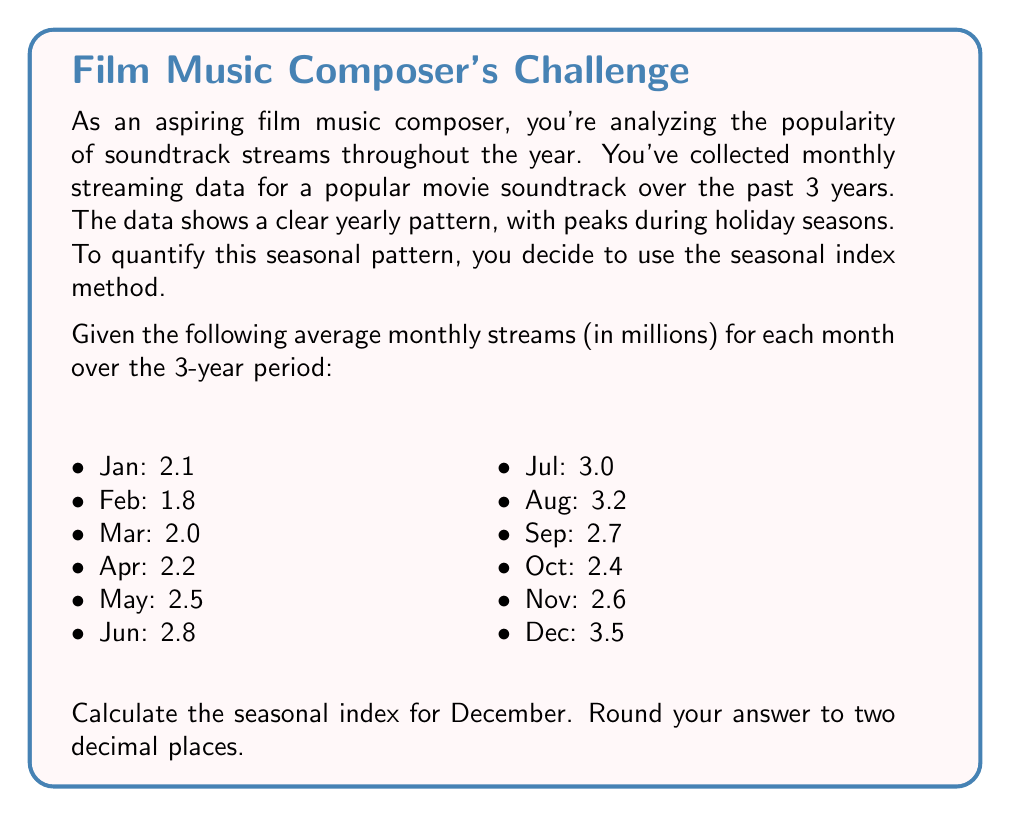Could you help me with this problem? To calculate the seasonal index for December, we'll follow these steps:

1. Calculate the grand mean (overall average) of all monthly averages:
   $$\text{Grand Mean} = \frac{\sum_{i=1}^{12} \text{Monthly Average}_i}{12}$$
   
   $$\text{Grand Mean} = \frac{2.1 + 1.8 + 2.0 + 2.2 + 2.5 + 2.8 + 3.0 + 3.2 + 2.7 + 2.4 + 2.6 + 3.5}{12} = 2.5667$$

2. Calculate the seasonal index for December:
   $$\text{Seasonal Index}_{\text{December}} = \frac{\text{December Average}}{\text{Grand Mean}} \times 100$$

   $$\text{Seasonal Index}_{\text{December}} = \frac{3.5}{2.5667} \times 100 = 136.36$$

3. Round the result to two decimal places:
   136.36

The seasonal index of 136.36 for December indicates that streaming in December is typically 36.36% higher than the overall average throughout the year.
Answer: 136.36 